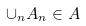Convert formula to latex. <formula><loc_0><loc_0><loc_500><loc_500>\cup _ { n } A _ { n } \in A</formula> 